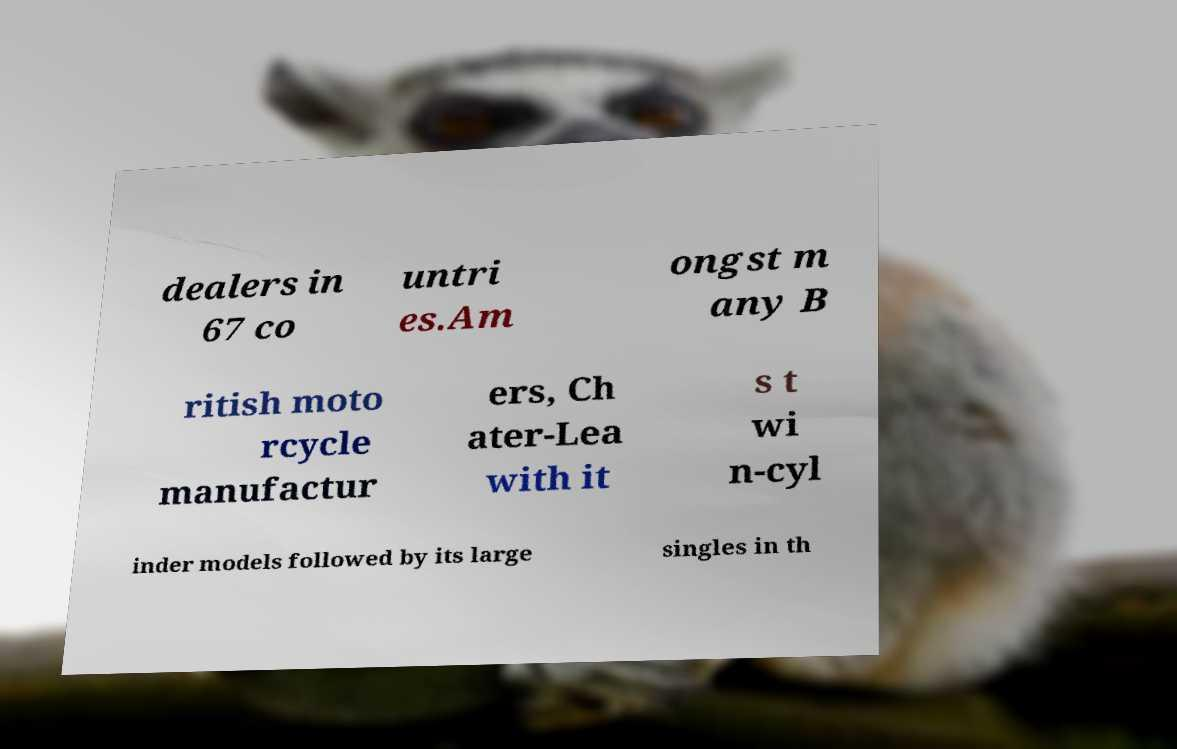I need the written content from this picture converted into text. Can you do that? dealers in 67 co untri es.Am ongst m any B ritish moto rcycle manufactur ers, Ch ater-Lea with it s t wi n-cyl inder models followed by its large singles in th 